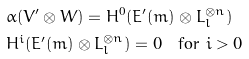Convert formula to latex. <formula><loc_0><loc_0><loc_500><loc_500>& \alpha ( V ^ { \prime } \otimes W ) = H ^ { 0 } ( E ^ { \prime } ( m ) \otimes L _ { l } ^ { \otimes n } ) \\ & H ^ { i } ( E ^ { \prime } ( m ) \otimes L _ { l } ^ { \otimes n } ) = 0 \quad \text {for $i>0$}</formula> 